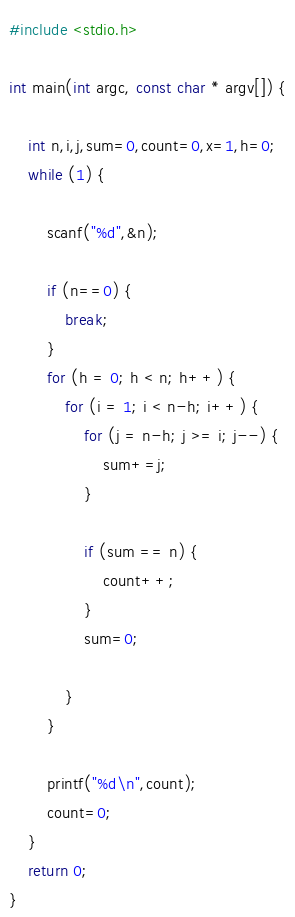Convert code to text. <code><loc_0><loc_0><loc_500><loc_500><_C_>#include <stdio.h>

int main(int argc, const char * argv[]) {
    
    int n,i,j,sum=0,count=0,x=1,h=0;
    while (1) {
        
        scanf("%d",&n);
        
        if (n==0) {
            break;
        }
        for (h = 0; h < n; h++) {
            for (i = 1; i < n-h; i++) {
                for (j = n-h; j >= i; j--) {
                    sum+=j;
                }
            
                if (sum == n) {
                    count++;
                }
                sum=0;
            
            }
        }
        
        printf("%d\n",count);
        count=0;
    }
    return 0;
}</code> 